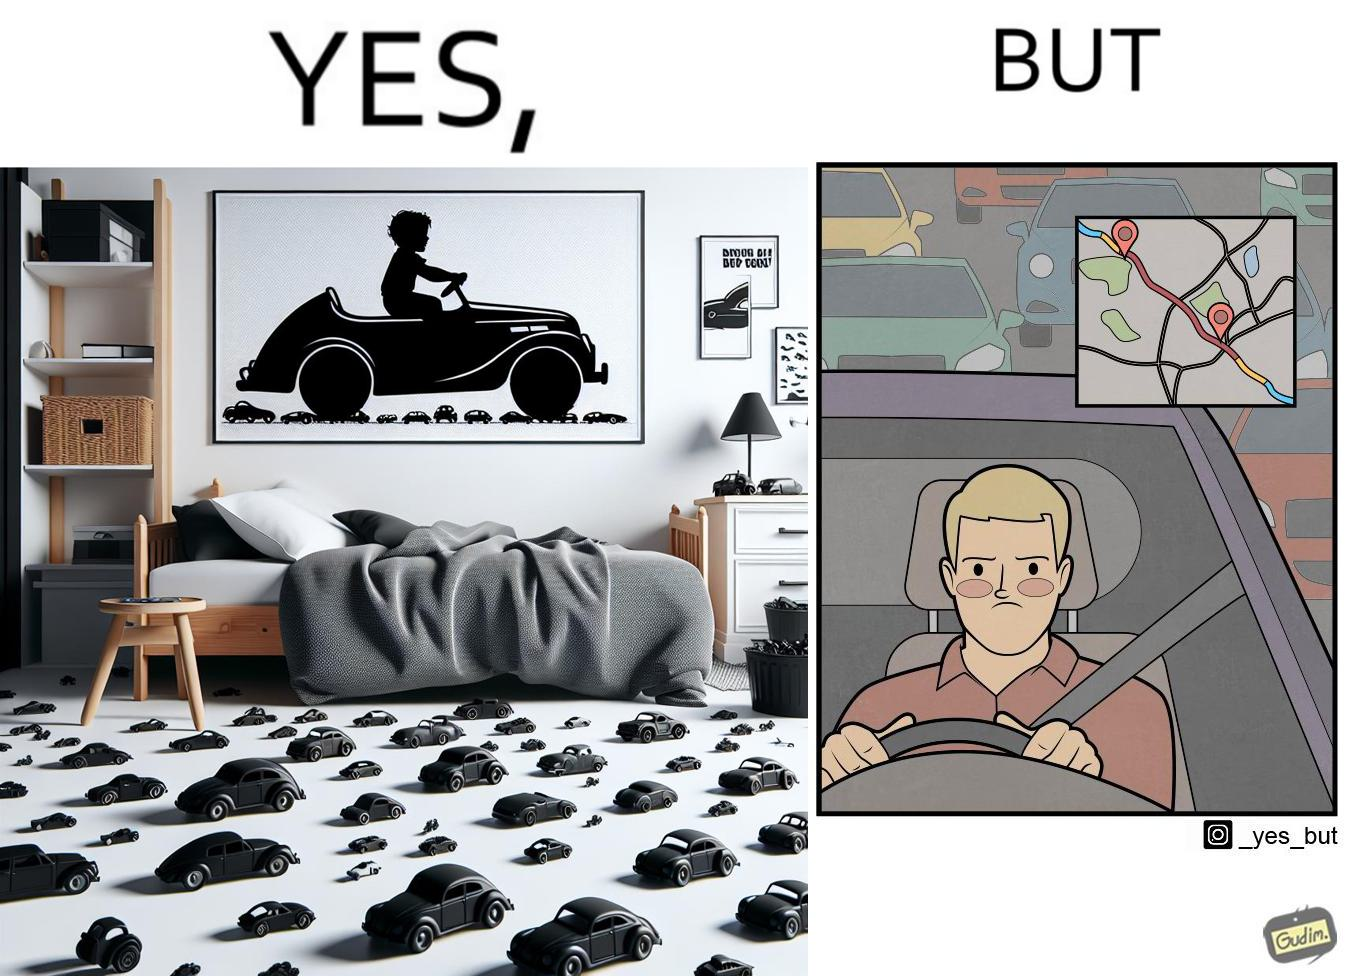Is this a satirical image? Yes, this image is satirical. 